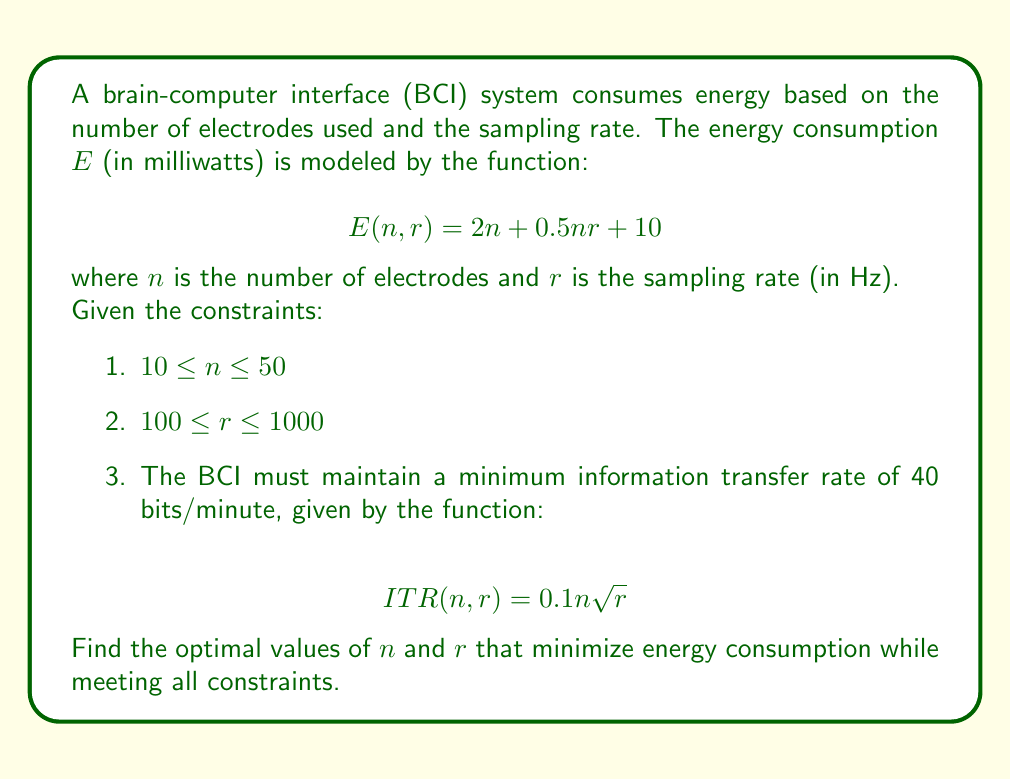What is the answer to this math problem? To solve this optimization problem, we'll use the method of Lagrange multipliers:

1. First, we need to convert the ITR constraint into an equality:
   $$0.1n\sqrt{r} = 40$$

2. We form the Lagrangian function:
   $$L(n, r, \lambda) = 2n + 0.5nr + 10 + \lambda(40 - 0.1n\sqrt{r})$$

3. We take partial derivatives and set them to zero:
   $$\frac{\partial L}{\partial n} = 2 + 0.5r - 0.1\lambda\sqrt{r} = 0$$
   $$\frac{\partial L}{\partial r} = 0.5n - 0.05\lambda n / \sqrt{r} = 0$$
   $$\frac{\partial L}{\partial \lambda} = 40 - 0.1n\sqrt{r} = 0$$

4. From the second equation:
   $$\lambda = 10\sqrt{r}$$

5. Substituting this into the first equation:
   $$2 + 0.5r - \sqrt{r} = 0$$
   $$0.5r - \sqrt{r} + 2 = 0$$

6. This is a quadratic in $\sqrt{r}$. Solving it:
   $$\sqrt{r} = 1 \text{ or } \sqrt{r} = 4$$
   $$r = 1 \text{ or } r = 16$$

7. Since $r$ must be between 100 and 1000, $r = 16$ is not valid. So $r = 100$.

8. From the ITR constraint:
   $$0.1n\sqrt{100} = 40$$
   $$n = 40$$

9. We need to check if these values satisfy all constraints:
   - $10 \leq n \leq 50$: Satisfied (40 is within range)
   - $100 \leq r \leq 1000$: Satisfied (r = 100)
   - ITR constraint: Satisfied by definition

Therefore, the optimal values are $n = 40$ and $r = 100$.
Answer: The optimal values that minimize energy consumption while meeting all constraints are:
Number of electrodes (n) = 40
Sampling rate (r) = 100 Hz
Resulting in minimum energy consumption of $E(40, 100) = 2(40) + 0.5(40)(100) + 10 = 2090$ milliwatts 